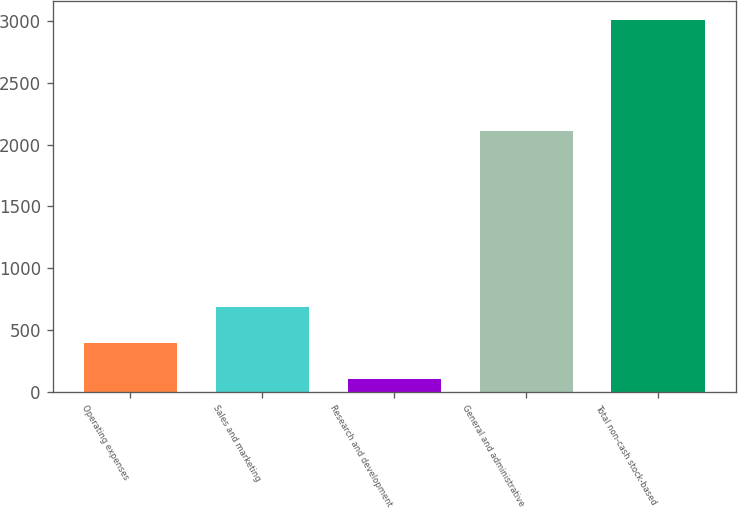Convert chart to OTSL. <chart><loc_0><loc_0><loc_500><loc_500><bar_chart><fcel>Operating expenses<fcel>Sales and marketing<fcel>Research and development<fcel>General and administrative<fcel>Total non-cash stock-based<nl><fcel>394.6<fcel>685.2<fcel>104<fcel>2112<fcel>3010<nl></chart> 